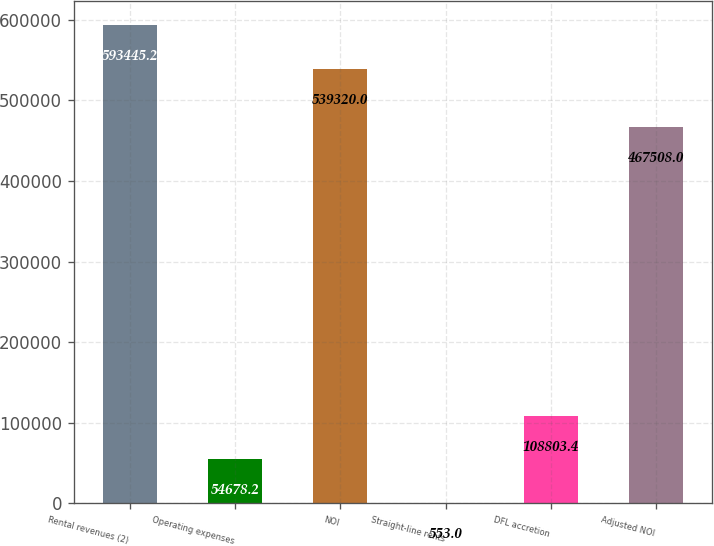<chart> <loc_0><loc_0><loc_500><loc_500><bar_chart><fcel>Rental revenues (2)<fcel>Operating expenses<fcel>NOI<fcel>Straight-line rents<fcel>DFL accretion<fcel>Adjusted NOI<nl><fcel>593445<fcel>54678.2<fcel>539320<fcel>553<fcel>108803<fcel>467508<nl></chart> 